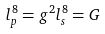Convert formula to latex. <formula><loc_0><loc_0><loc_500><loc_500>l _ { p } ^ { 8 } = g ^ { 2 } l _ { s } ^ { 8 } = G</formula> 